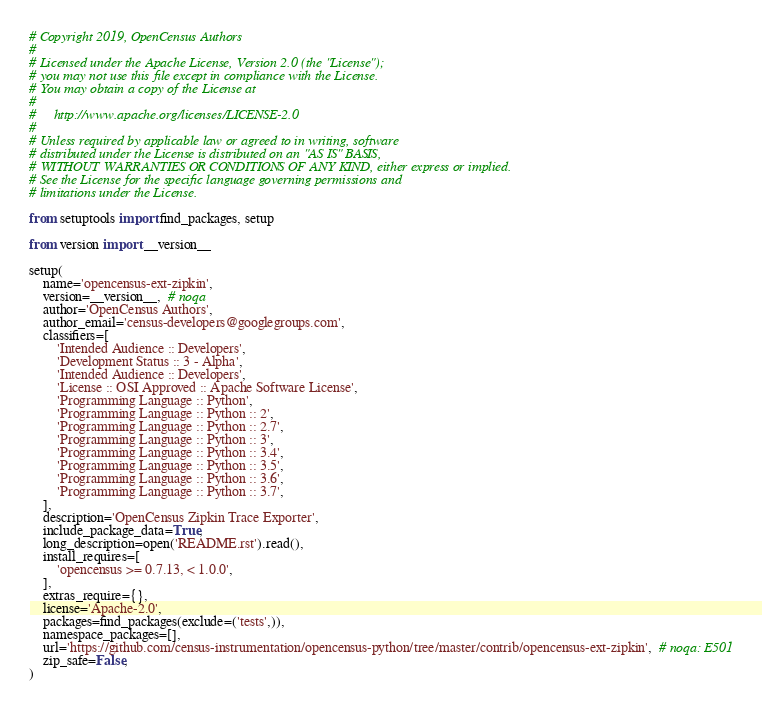<code> <loc_0><loc_0><loc_500><loc_500><_Python_># Copyright 2019, OpenCensus Authors
#
# Licensed under the Apache License, Version 2.0 (the "License");
# you may not use this file except in compliance with the License.
# You may obtain a copy of the License at
#
#     http://www.apache.org/licenses/LICENSE-2.0
#
# Unless required by applicable law or agreed to in writing, software
# distributed under the License is distributed on an "AS IS" BASIS,
# WITHOUT WARRANTIES OR CONDITIONS OF ANY KIND, either express or implied.
# See the License for the specific language governing permissions and
# limitations under the License.

from setuptools import find_packages, setup

from version import __version__

setup(
    name='opencensus-ext-zipkin',
    version=__version__,  # noqa
    author='OpenCensus Authors',
    author_email='census-developers@googlegroups.com',
    classifiers=[
        'Intended Audience :: Developers',
        'Development Status :: 3 - Alpha',
        'Intended Audience :: Developers',
        'License :: OSI Approved :: Apache Software License',
        'Programming Language :: Python',
        'Programming Language :: Python :: 2',
        'Programming Language :: Python :: 2.7',
        'Programming Language :: Python :: 3',
        'Programming Language :: Python :: 3.4',
        'Programming Language :: Python :: 3.5',
        'Programming Language :: Python :: 3.6',
        'Programming Language :: Python :: 3.7',
    ],
    description='OpenCensus Zipkin Trace Exporter',
    include_package_data=True,
    long_description=open('README.rst').read(),
    install_requires=[
        'opencensus >= 0.7.13, < 1.0.0',
    ],
    extras_require={},
    license='Apache-2.0',
    packages=find_packages(exclude=('tests',)),
    namespace_packages=[],
    url='https://github.com/census-instrumentation/opencensus-python/tree/master/contrib/opencensus-ext-zipkin',  # noqa: E501
    zip_safe=False,
)
</code> 